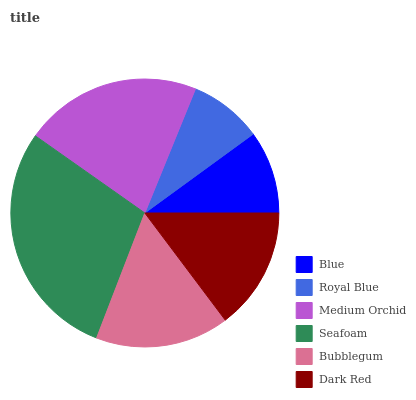Is Royal Blue the minimum?
Answer yes or no. Yes. Is Seafoam the maximum?
Answer yes or no. Yes. Is Medium Orchid the minimum?
Answer yes or no. No. Is Medium Orchid the maximum?
Answer yes or no. No. Is Medium Orchid greater than Royal Blue?
Answer yes or no. Yes. Is Royal Blue less than Medium Orchid?
Answer yes or no. Yes. Is Royal Blue greater than Medium Orchid?
Answer yes or no. No. Is Medium Orchid less than Royal Blue?
Answer yes or no. No. Is Bubblegum the high median?
Answer yes or no. Yes. Is Dark Red the low median?
Answer yes or no. Yes. Is Blue the high median?
Answer yes or no. No. Is Blue the low median?
Answer yes or no. No. 